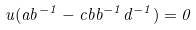Convert formula to latex. <formula><loc_0><loc_0><loc_500><loc_500>u ( a b ^ { - 1 } - c b b ^ { - 1 } d ^ { - 1 } ) = 0</formula> 